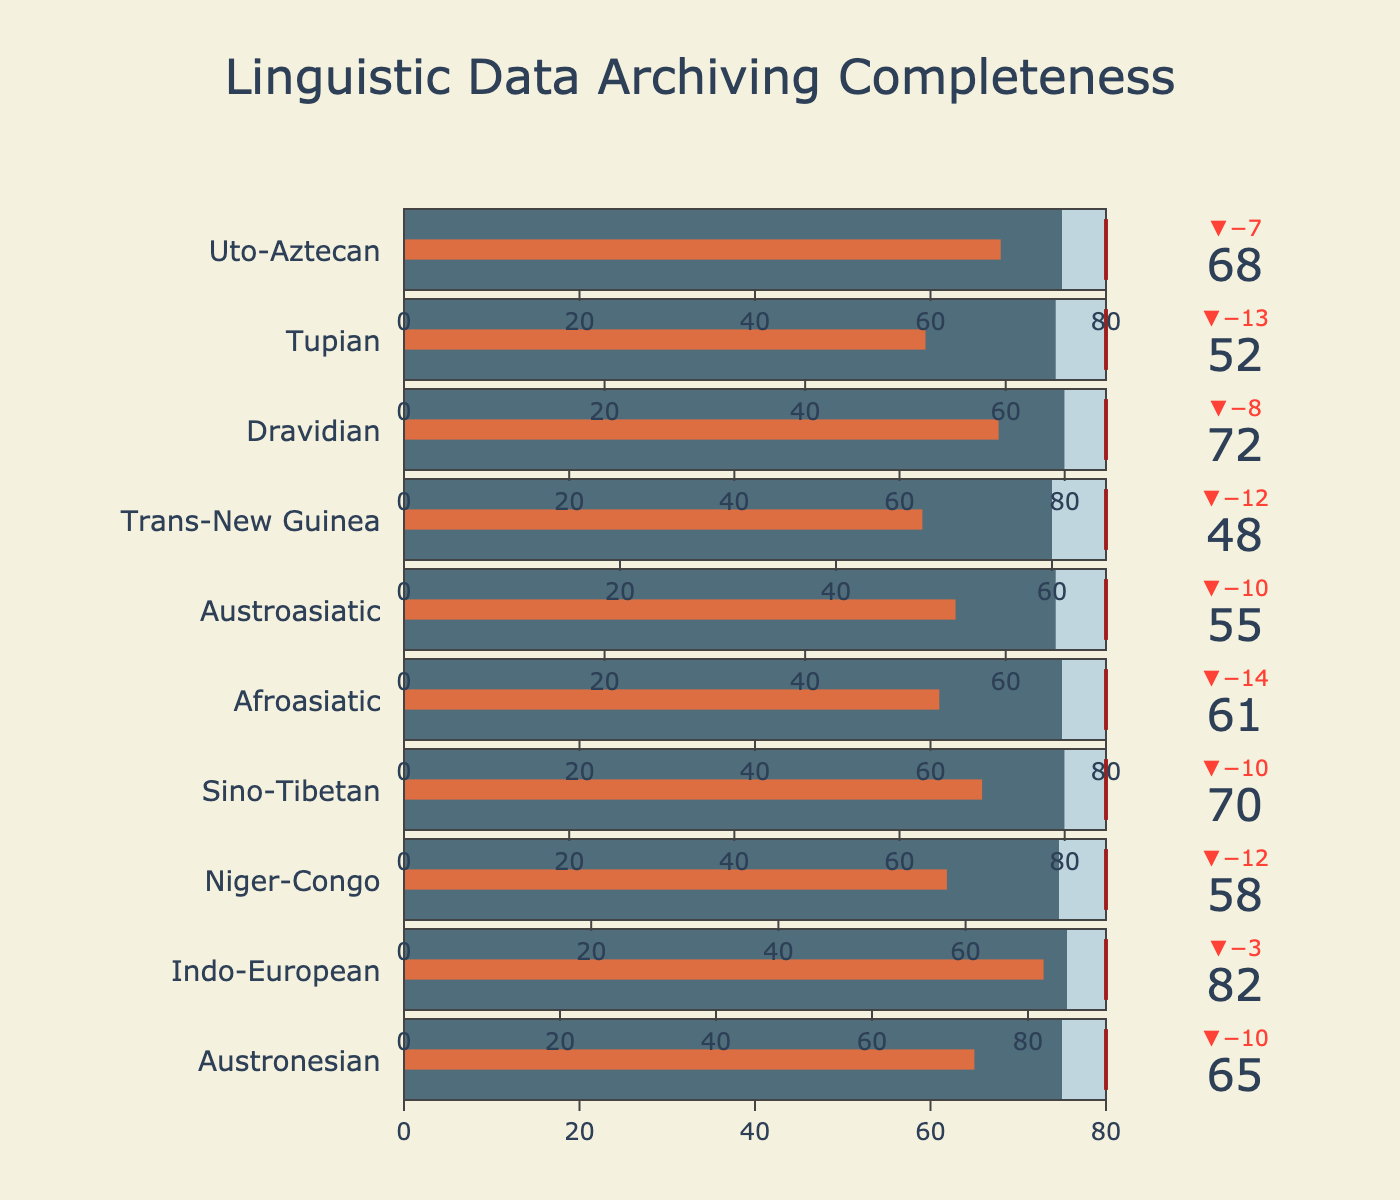What is the title of the figure? The title is written at the top center of the figure. It reads "Linguistic Data Archiving Completeness."
Answer: Linguistic Data Archiving Completeness How many language families are represented in the bullet chart? By counting the rows of bullet indicators in the figure, we can see that there are 10 language families listed.
Answer: 10 Which language family has the highest actual data archiving completeness? By comparing all the 'Actual' values, Indo-European has the highest actual completeness with a value of 82.
Answer: Indo-European Which language family has the lowest actual data archiving completeness? By comparing all the 'Actual' values, Trans-New Guinea has the lowest actual completeness with a value of 48.
Answer: Trans-New Guinea What is the target value for the Afroasiatic language family? Look at the red threshold line for the Afroasiatic row. The target value marked is 80.
Answer: 80 Which language family exceeds its comparative value by the largest margin? Compare the differences between 'Actual' and 'Comparative' values for each family. Indo-European exceeds its comparative value (82 - 85) by 3.
Answer: Indo-European How does the actual completeness of the Dravidian family compare to its comparative value? Subtract the comparative value from the actual value for Dravidian. 72 - 80 = -8, so Dravidian's completeness is 8 units below its comparative value.
Answer: 8 units below What is the average target value across all language families? Sum all target values (80 + 90 + 75 + 85 + 80 + 70 + 65 + 85 + 70 + 80) = 780, and divide by the number of families (10). 780 / 10 = 78.
Answer: 78 Which language family has a target value of 85? Look for the family whose target value is 85, this matches Sino-Tibetan and Dravidian families.
Answer: Sino-Tibetan, Dravidian How does the archiving completeness of Austronesian compare to Uto-Aztecan? Compare the 'Actual' values of Austronesian (65) and Uto-Aztecan (68). Austronesian is 3 units less complete than Uto-Aztecan.
Answer: 3 units less complete 